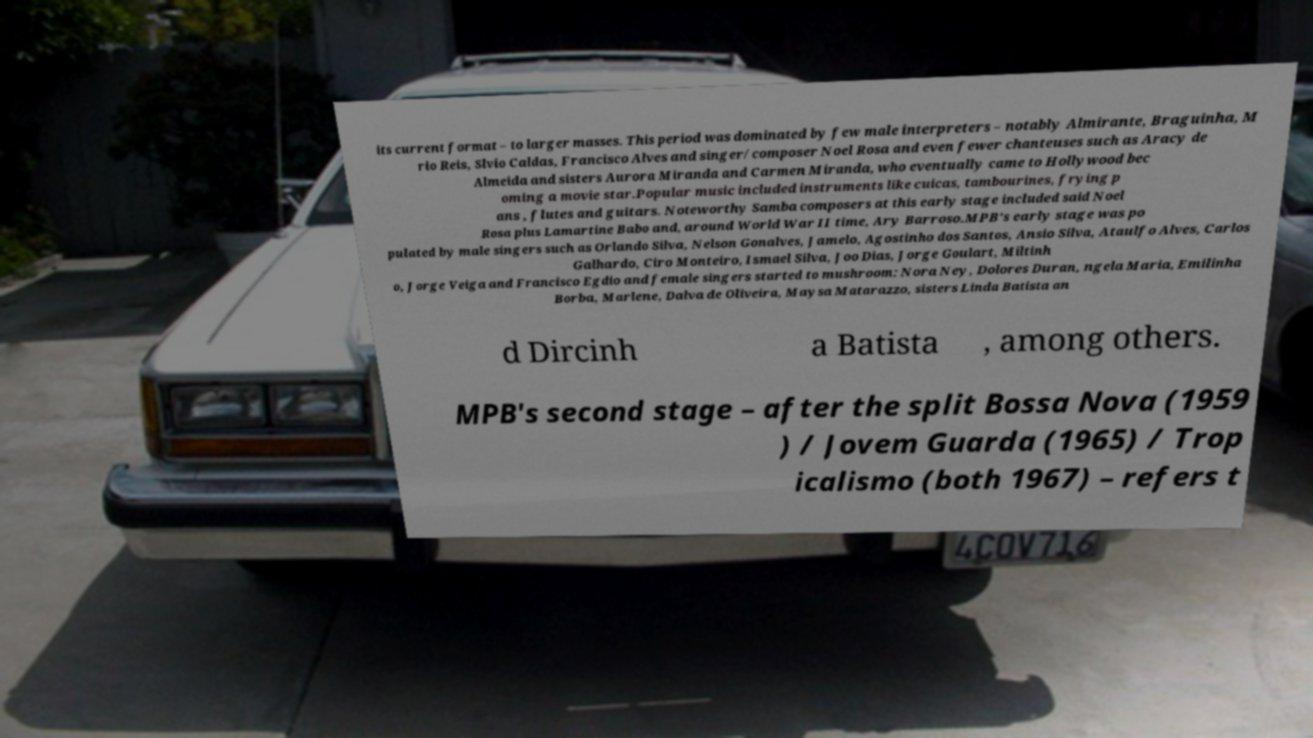What messages or text are displayed in this image? I need them in a readable, typed format. its current format – to larger masses. This period was dominated by few male interpreters – notably Almirante, Braguinha, M rio Reis, Slvio Caldas, Francisco Alves and singer/composer Noel Rosa and even fewer chanteuses such as Aracy de Almeida and sisters Aurora Miranda and Carmen Miranda, who eventually came to Hollywood bec oming a movie star.Popular music included instruments like cuicas, tambourines, frying p ans , flutes and guitars. Noteworthy Samba composers at this early stage included said Noel Rosa plus Lamartine Babo and, around World War II time, Ary Barroso.MPB's early stage was po pulated by male singers such as Orlando Silva, Nelson Gonalves, Jamelo, Agostinho dos Santos, Ansio Silva, Ataulfo Alves, Carlos Galhardo, Ciro Monteiro, Ismael Silva, Joo Dias, Jorge Goulart, Miltinh o, Jorge Veiga and Francisco Egdio and female singers started to mushroom: Nora Ney, Dolores Duran, ngela Maria, Emilinha Borba, Marlene, Dalva de Oliveira, Maysa Matarazzo, sisters Linda Batista an d Dircinh a Batista , among others. MPB's second stage – after the split Bossa Nova (1959 ) / Jovem Guarda (1965) / Trop icalismo (both 1967) – refers t 